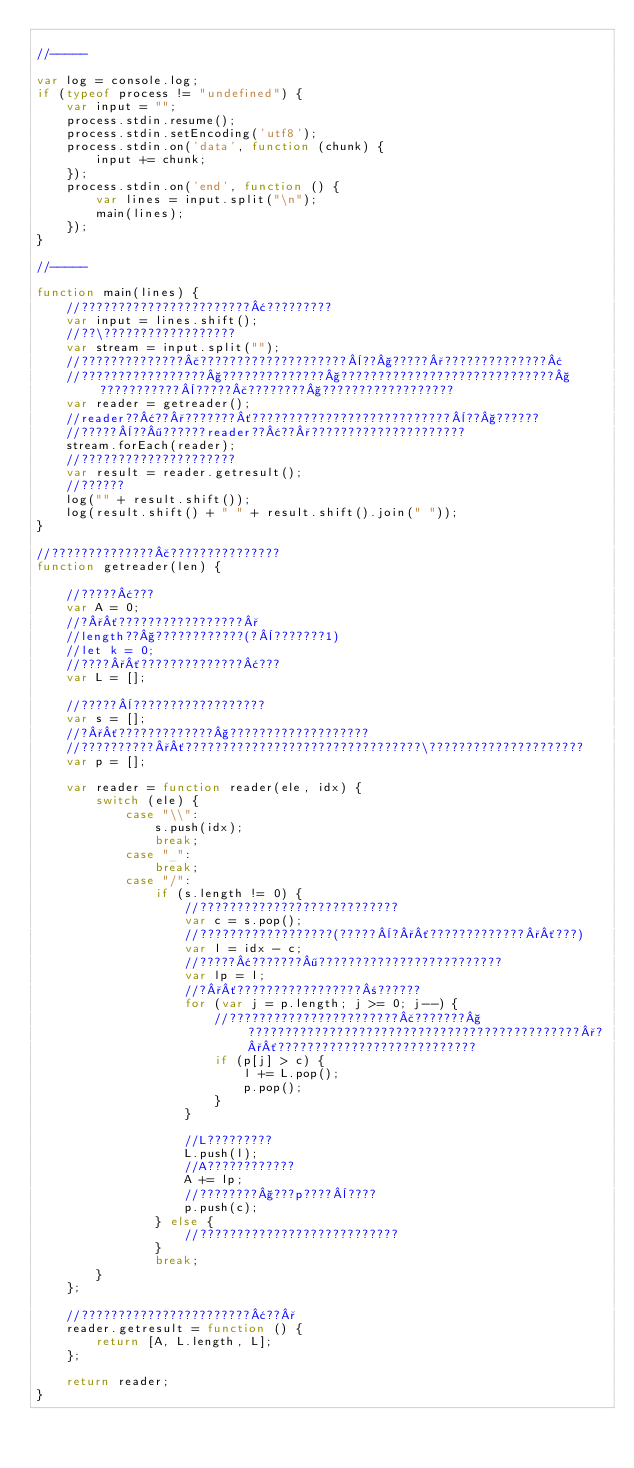<code> <loc_0><loc_0><loc_500><loc_500><_JavaScript_>
//-----

var log = console.log;
if (typeof process != "undefined") {
	var input = "";
	process.stdin.resume();
	process.stdin.setEncoding('utf8');
	process.stdin.on('data', function (chunk) {
		input += chunk;
	});
	process.stdin.on('end', function () {
		var lines = input.split("\n");
		main(lines);
	});
}

//-----

function main(lines) {
	//???????????????????????¢?????????
	var input = lines.shift();
	//??\??????????????????
	var stream = input.split("");
	//??????????????£????????????????????¨??§?????°??????????????¢
	//?????????????????§??????????????§?????????????????????????????§???????????¨?????£????????§??????????????????
	var reader = getreader();
	//reader??¢??°???????´???????????????????????????¨??§??????
	//?????¨??¶??????reader??¢??°?????????????????????
	stream.forEach(reader);
	//?????????????????????
	var result = reader.getresult();
	//??????
	log("" + result.shift());
	log(result.shift() + " " + result.shift().join(" "));
}

//??????????????£???????????????
function getreader(len) {

	//?????¢???
	var A = 0;
	//?°´?????????????????°
	//length??§????????????(?¨???????1)
	//let k = 0;
	//????°´??????????????¢???
	var L = [];

	//?????¨??????????????????
	var s = [];
	//?°´?????????????§???????????????????
	//??????????°´????????????????????????????????\?????????????????????
	var p = [];

	var reader = function reader(ele, idx) {
		switch (ele) {
			case "\\":
				s.push(idx);
				break;
			case "_":
				break;
			case "/":
				if (s.length != 0) {
					//???????????????????????????
					var c = s.pop();
					//??????????????????(?????¨?°´?????????????°´???)
					var l = idx - c;
					//?????¢???????¶?????????????????????????
					var lp = l;
					//?°´?????????????????±??????
					for (var j = p.length; j >= 0; j--) {
						//???????????????????????£???????§?????????????????????????????????????????????°?°´???????????????????????????
						if (p[j] > c) {
							l += L.pop();
							p.pop();
						}
					}

					//L?????????
					L.push(l);
					//A????????????
					A += lp;
					//????????§???p????¨????
					p.push(c);
				} else {
					//???????????????????????????
				}
				break;
		}
	};

	//???????????????????????¢??°
	reader.getresult = function () {
		return [A, L.length, L];
	};

	return reader;
}</code> 